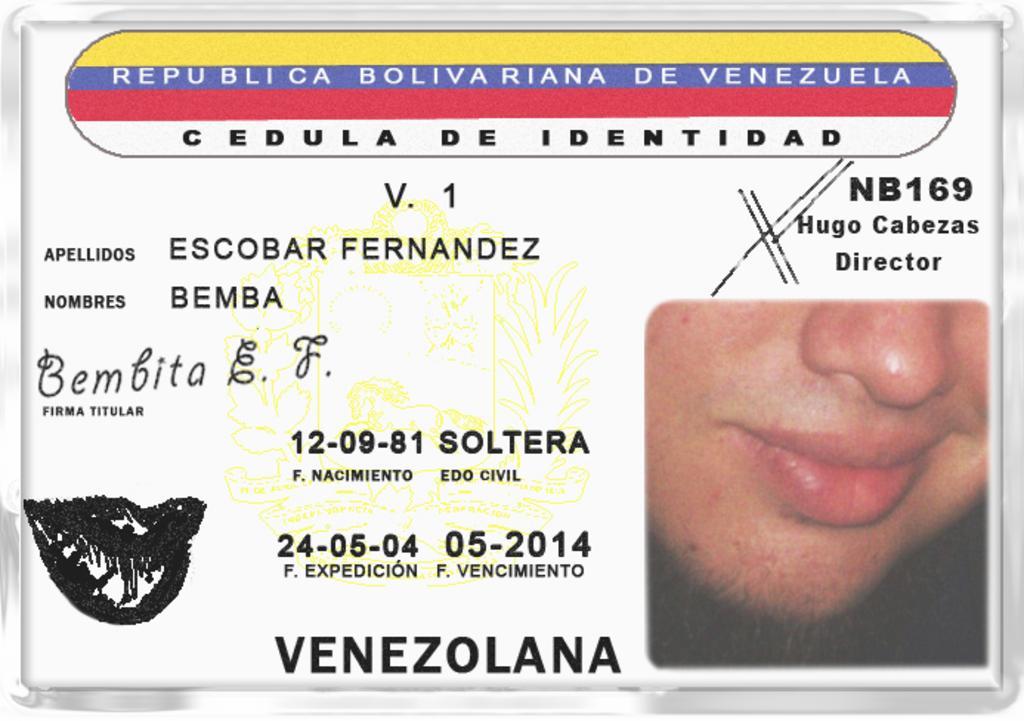Can you describe this image briefly? In this image I can see half face of a person. Here I can see something is written at few places and I can also see white colour in background. 